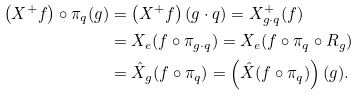<formula> <loc_0><loc_0><loc_500><loc_500>\left ( X ^ { + } f \right ) \circ \pi _ { q } ( g ) & = \left ( X ^ { + } f \right ) ( g \cdot q ) = X ^ { + } _ { g \cdot q } ( f ) \\ & = X _ { e } ( f \circ \pi _ { g \cdot q } ) = X _ { e } ( f \circ \pi _ { q } \circ R _ { g } ) \\ & = \hat { X } _ { g } ( f \circ \pi _ { q } ) = \left ( \hat { X } ( f \circ \pi _ { q } ) \right ) ( g ) .</formula> 